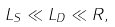Convert formula to latex. <formula><loc_0><loc_0><loc_500><loc_500>L _ { S } \ll L _ { D } \ll R ,</formula> 